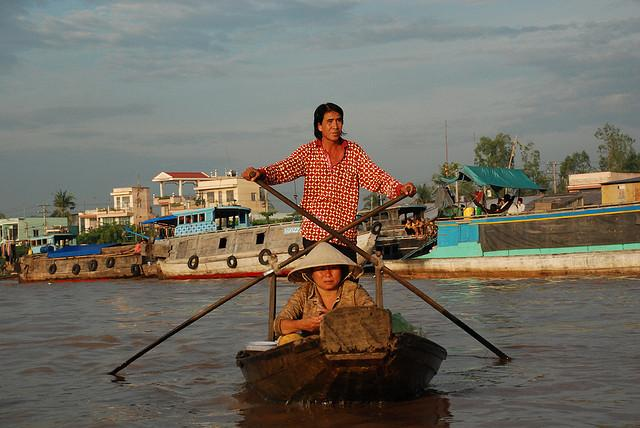What shape are the oars forming? Please explain your reasoning. cross. A man is staning on a boat. he has the oars crisscrossed making an x. 